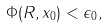<formula> <loc_0><loc_0><loc_500><loc_500>\Phi ( R , x _ { 0 } ) < \epsilon _ { 0 } ,</formula> 